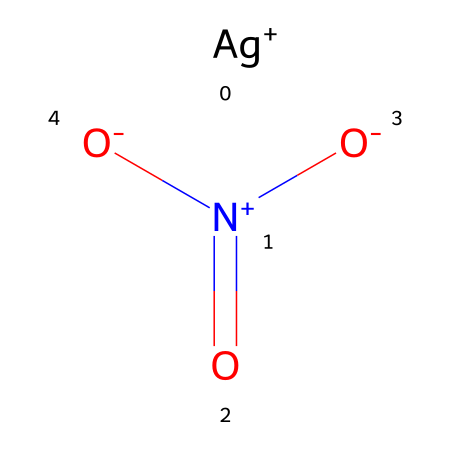What is the chemical name of this compound? The SMILES representation indicates the presence of silver (Ag) and nitrate (Nitrate being NO3), identifying the compound as silver nitrate.
Answer: silver nitrate How many oxygen atoms are present in silver nitrate? By examining the SMILES notation, we can see three oxygen atoms indicated by the three [O] groups connected to nitrogen.
Answer: three What is the oxidation state of silver in this compound? The notation [Ag+] shows that silver has a +1 oxidation state.
Answer: +1 Which element in silver nitrate is responsible for its oxidizing properties? The nitrogen atom in nitrate has a high oxidation state (being part of a -1 charged ion), leading to oxidizing behavior.
Answer: nitrogen How many total atoms comprise silver nitrate? Counting all the atoms in the SMILES representation: 1 silver (Ag), 1 nitrogen (N), and 3 oxygens (O), leads to a total of 5 atoms.
Answer: five What type of ions does silver nitrate release in solution? Upon dissociation, silver nitrate produces Ag+ (silver ion) and NO3- (nitrate ion). The presence of these ions indicates its behavior in reactions, particularly oxidation.
Answer: silver ion and nitrate ion 